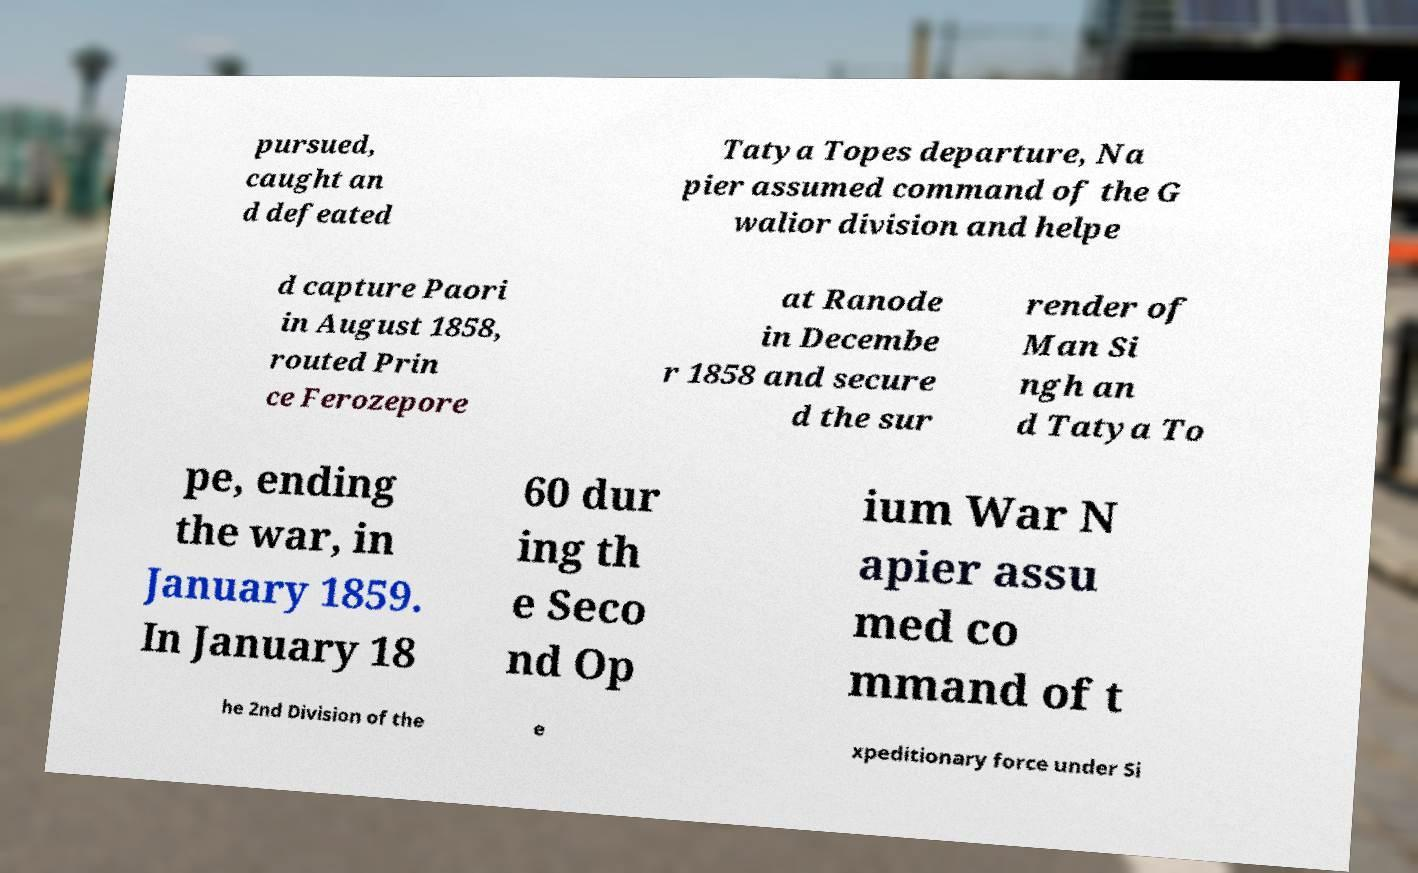Can you accurately transcribe the text from the provided image for me? pursued, caught an d defeated Tatya Topes departure, Na pier assumed command of the G walior division and helpe d capture Paori in August 1858, routed Prin ce Ferozepore at Ranode in Decembe r 1858 and secure d the sur render of Man Si ngh an d Tatya To pe, ending the war, in January 1859. In January 18 60 dur ing th e Seco nd Op ium War N apier assu med co mmand of t he 2nd Division of the e xpeditionary force under Si 